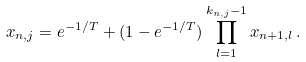<formula> <loc_0><loc_0><loc_500><loc_500>x _ { n , j } = e ^ { - 1 / T } + ( 1 - e ^ { - 1 / T } ) \prod _ { l = 1 } ^ { k _ { n , j } - 1 } x _ { n + 1 , l } \, .</formula> 